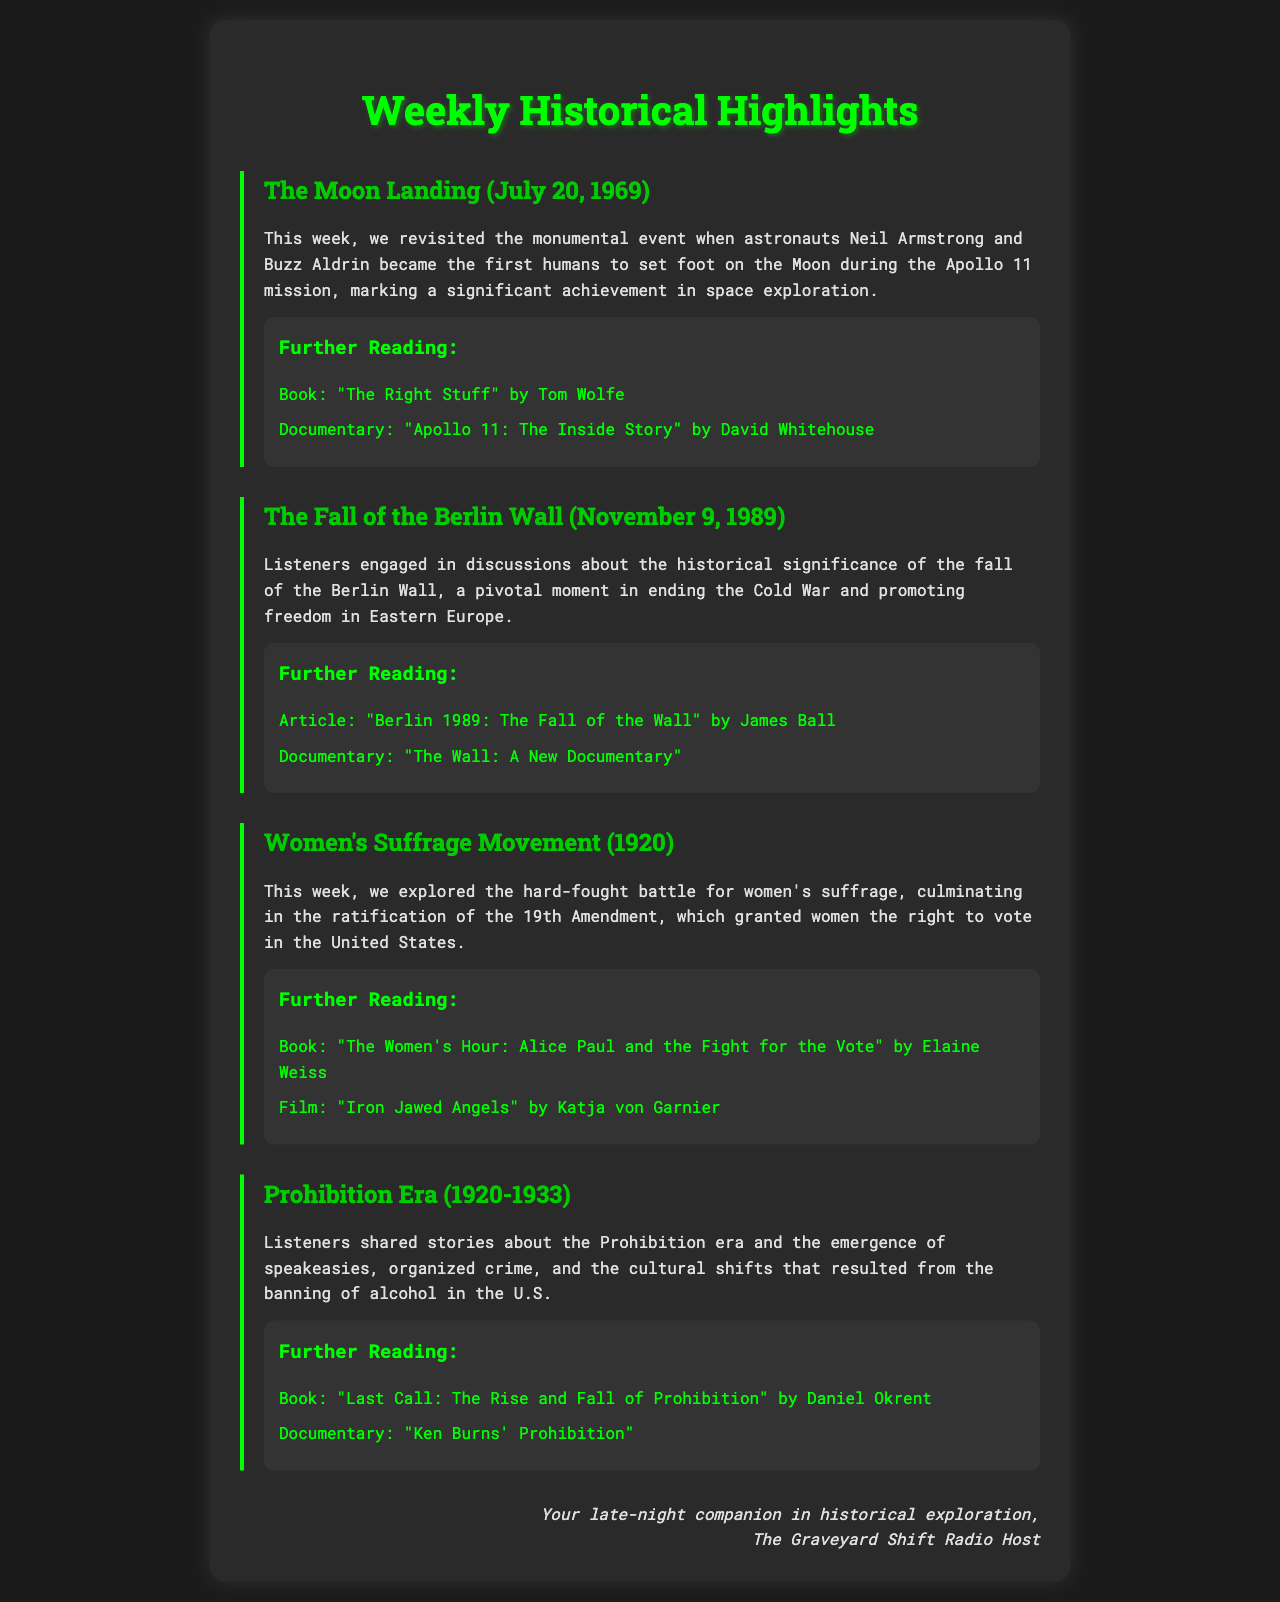What event took place on July 20, 1969? The event is the Moon landing where astronauts Neil Armstrong and Buzz Aldrin became the first humans to set foot on the Moon during the Apollo 11 mission.
Answer: Moon landing When did the Berlin Wall fall? The Berlin Wall fell on November 9, 1989.
Answer: November 9, 1989 What significant amendment was ratified in 1920? The 19th Amendment was ratified, granting women the right to vote in the United States.
Answer: 19th Amendment Who wrote "The Right Stuff"? "The Right Stuff" was written by Tom Wolfe.
Answer: Tom Wolfe What cultural phenomenon emerged during the Prohibition era? Speakeasies emerged during the Prohibition era.
Answer: Speakeasies Which documentary discusses the Apollo 11 mission? The documentary is "Apollo 11: The Inside Story" by David Whitehouse.
Answer: Apollo 11: The Inside Story What was one of the outcomes of the fall of the Berlin Wall? It was a pivotal moment in ending the Cold War and promoting freedom in Eastern Europe.
Answer: Ending the Cold War What year did the Women’s Suffrage Movement culminate? The Women’s Suffrage Movement culminated in 1920.
Answer: 1920 Which film portrays the fight for women's voting rights? The film is "Iron Jawed Angels" by Katja von Garnier.
Answer: Iron Jawed Angels 